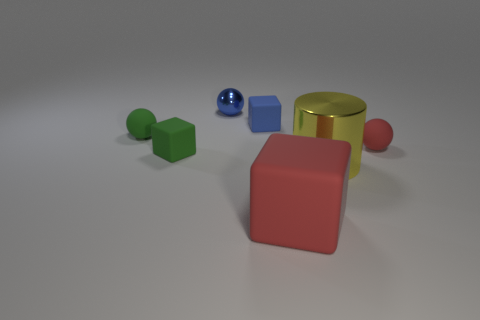Subtract all small rubber balls. How many balls are left? 1 Add 1 tiny green matte cubes. How many objects exist? 8 Subtract all red spheres. How many spheres are left? 2 Add 1 metallic things. How many metallic things are left? 3 Add 6 small cubes. How many small cubes exist? 8 Subtract 0 purple balls. How many objects are left? 7 Subtract all spheres. How many objects are left? 4 Subtract 2 spheres. How many spheres are left? 1 Subtract all gray spheres. Subtract all yellow cubes. How many spheres are left? 3 Subtract all tiny gray metal cubes. Subtract all big yellow cylinders. How many objects are left? 6 